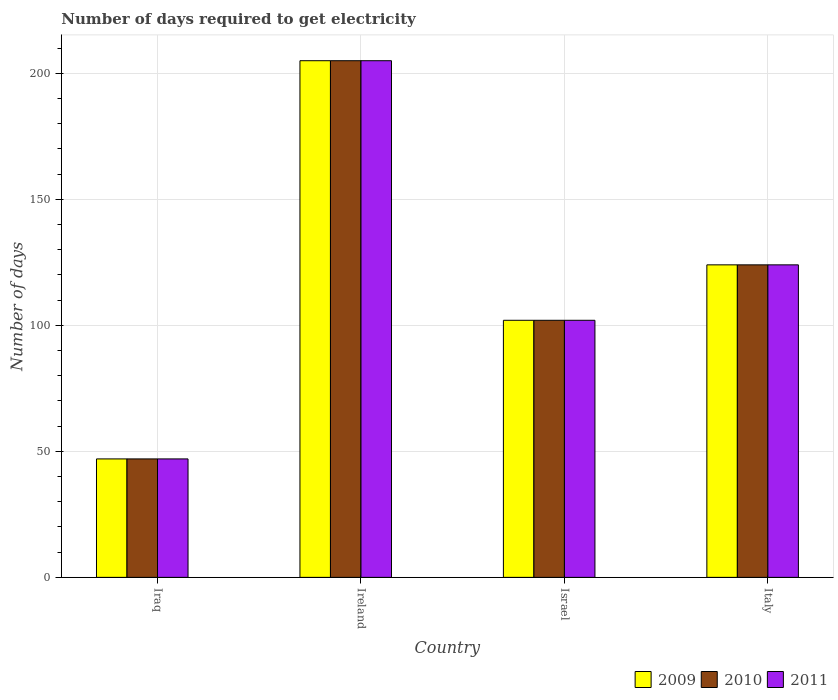How many different coloured bars are there?
Ensure brevity in your answer.  3. Are the number of bars per tick equal to the number of legend labels?
Offer a very short reply. Yes. What is the label of the 1st group of bars from the left?
Offer a very short reply. Iraq. What is the number of days required to get electricity in in 2011 in Israel?
Ensure brevity in your answer.  102. Across all countries, what is the maximum number of days required to get electricity in in 2011?
Your response must be concise. 205. In which country was the number of days required to get electricity in in 2009 maximum?
Provide a short and direct response. Ireland. In which country was the number of days required to get electricity in in 2011 minimum?
Your answer should be very brief. Iraq. What is the total number of days required to get electricity in in 2010 in the graph?
Your answer should be compact. 478. What is the difference between the number of days required to get electricity in in 2011 in Ireland and that in Italy?
Ensure brevity in your answer.  81. What is the difference between the number of days required to get electricity in in 2010 in Italy and the number of days required to get electricity in in 2009 in Iraq?
Your answer should be compact. 77. What is the average number of days required to get electricity in in 2010 per country?
Give a very brief answer. 119.5. In how many countries, is the number of days required to get electricity in in 2011 greater than 20 days?
Your response must be concise. 4. What is the ratio of the number of days required to get electricity in in 2010 in Iraq to that in Ireland?
Offer a terse response. 0.23. Is the difference between the number of days required to get electricity in in 2009 in Iraq and Ireland greater than the difference between the number of days required to get electricity in in 2011 in Iraq and Ireland?
Offer a very short reply. No. What is the difference between the highest and the second highest number of days required to get electricity in in 2011?
Your answer should be very brief. -81. What is the difference between the highest and the lowest number of days required to get electricity in in 2009?
Your answer should be very brief. 158. What does the 2nd bar from the left in Ireland represents?
Your response must be concise. 2010. What does the 3rd bar from the right in Italy represents?
Your answer should be very brief. 2009. How many bars are there?
Offer a terse response. 12. Are all the bars in the graph horizontal?
Your answer should be very brief. No. How many countries are there in the graph?
Keep it short and to the point. 4. What is the difference between two consecutive major ticks on the Y-axis?
Offer a terse response. 50. Does the graph contain any zero values?
Make the answer very short. No. Does the graph contain grids?
Your response must be concise. Yes. How are the legend labels stacked?
Make the answer very short. Horizontal. What is the title of the graph?
Make the answer very short. Number of days required to get electricity. Does "1998" appear as one of the legend labels in the graph?
Keep it short and to the point. No. What is the label or title of the X-axis?
Make the answer very short. Country. What is the label or title of the Y-axis?
Ensure brevity in your answer.  Number of days. What is the Number of days of 2009 in Iraq?
Give a very brief answer. 47. What is the Number of days in 2011 in Iraq?
Your answer should be very brief. 47. What is the Number of days in 2009 in Ireland?
Ensure brevity in your answer.  205. What is the Number of days of 2010 in Ireland?
Give a very brief answer. 205. What is the Number of days in 2011 in Ireland?
Ensure brevity in your answer.  205. What is the Number of days of 2009 in Israel?
Your answer should be very brief. 102. What is the Number of days of 2010 in Israel?
Provide a short and direct response. 102. What is the Number of days in 2011 in Israel?
Your answer should be very brief. 102. What is the Number of days in 2009 in Italy?
Offer a terse response. 124. What is the Number of days in 2010 in Italy?
Provide a succinct answer. 124. What is the Number of days in 2011 in Italy?
Provide a short and direct response. 124. Across all countries, what is the maximum Number of days of 2009?
Ensure brevity in your answer.  205. Across all countries, what is the maximum Number of days in 2010?
Your answer should be compact. 205. Across all countries, what is the maximum Number of days in 2011?
Ensure brevity in your answer.  205. What is the total Number of days of 2009 in the graph?
Provide a short and direct response. 478. What is the total Number of days in 2010 in the graph?
Offer a very short reply. 478. What is the total Number of days in 2011 in the graph?
Keep it short and to the point. 478. What is the difference between the Number of days of 2009 in Iraq and that in Ireland?
Provide a short and direct response. -158. What is the difference between the Number of days of 2010 in Iraq and that in Ireland?
Provide a succinct answer. -158. What is the difference between the Number of days of 2011 in Iraq and that in Ireland?
Your answer should be very brief. -158. What is the difference between the Number of days in 2009 in Iraq and that in Israel?
Ensure brevity in your answer.  -55. What is the difference between the Number of days of 2010 in Iraq and that in Israel?
Ensure brevity in your answer.  -55. What is the difference between the Number of days of 2011 in Iraq and that in Israel?
Offer a terse response. -55. What is the difference between the Number of days of 2009 in Iraq and that in Italy?
Your response must be concise. -77. What is the difference between the Number of days in 2010 in Iraq and that in Italy?
Provide a succinct answer. -77. What is the difference between the Number of days in 2011 in Iraq and that in Italy?
Make the answer very short. -77. What is the difference between the Number of days of 2009 in Ireland and that in Israel?
Ensure brevity in your answer.  103. What is the difference between the Number of days in 2010 in Ireland and that in Israel?
Provide a short and direct response. 103. What is the difference between the Number of days in 2011 in Ireland and that in Israel?
Offer a terse response. 103. What is the difference between the Number of days of 2009 in Ireland and that in Italy?
Provide a short and direct response. 81. What is the difference between the Number of days of 2011 in Ireland and that in Italy?
Offer a terse response. 81. What is the difference between the Number of days in 2009 in Israel and that in Italy?
Give a very brief answer. -22. What is the difference between the Number of days of 2010 in Israel and that in Italy?
Offer a terse response. -22. What is the difference between the Number of days of 2011 in Israel and that in Italy?
Offer a very short reply. -22. What is the difference between the Number of days in 2009 in Iraq and the Number of days in 2010 in Ireland?
Provide a short and direct response. -158. What is the difference between the Number of days in 2009 in Iraq and the Number of days in 2011 in Ireland?
Ensure brevity in your answer.  -158. What is the difference between the Number of days of 2010 in Iraq and the Number of days of 2011 in Ireland?
Offer a terse response. -158. What is the difference between the Number of days in 2009 in Iraq and the Number of days in 2010 in Israel?
Your answer should be compact. -55. What is the difference between the Number of days in 2009 in Iraq and the Number of days in 2011 in Israel?
Offer a terse response. -55. What is the difference between the Number of days of 2010 in Iraq and the Number of days of 2011 in Israel?
Provide a succinct answer. -55. What is the difference between the Number of days of 2009 in Iraq and the Number of days of 2010 in Italy?
Ensure brevity in your answer.  -77. What is the difference between the Number of days in 2009 in Iraq and the Number of days in 2011 in Italy?
Offer a very short reply. -77. What is the difference between the Number of days of 2010 in Iraq and the Number of days of 2011 in Italy?
Provide a short and direct response. -77. What is the difference between the Number of days of 2009 in Ireland and the Number of days of 2010 in Israel?
Offer a terse response. 103. What is the difference between the Number of days of 2009 in Ireland and the Number of days of 2011 in Israel?
Make the answer very short. 103. What is the difference between the Number of days in 2010 in Ireland and the Number of days in 2011 in Israel?
Offer a very short reply. 103. What is the difference between the Number of days in 2009 in Ireland and the Number of days in 2010 in Italy?
Ensure brevity in your answer.  81. What is the average Number of days of 2009 per country?
Your response must be concise. 119.5. What is the average Number of days of 2010 per country?
Ensure brevity in your answer.  119.5. What is the average Number of days in 2011 per country?
Your answer should be compact. 119.5. What is the difference between the Number of days of 2009 and Number of days of 2010 in Iraq?
Your answer should be compact. 0. What is the difference between the Number of days of 2009 and Number of days of 2011 in Iraq?
Provide a short and direct response. 0. What is the difference between the Number of days in 2010 and Number of days in 2011 in Iraq?
Ensure brevity in your answer.  0. What is the difference between the Number of days of 2009 and Number of days of 2010 in Ireland?
Offer a very short reply. 0. What is the difference between the Number of days of 2009 and Number of days of 2011 in Israel?
Offer a very short reply. 0. What is the difference between the Number of days of 2010 and Number of days of 2011 in Israel?
Give a very brief answer. 0. What is the ratio of the Number of days in 2009 in Iraq to that in Ireland?
Keep it short and to the point. 0.23. What is the ratio of the Number of days in 2010 in Iraq to that in Ireland?
Make the answer very short. 0.23. What is the ratio of the Number of days of 2011 in Iraq to that in Ireland?
Your response must be concise. 0.23. What is the ratio of the Number of days in 2009 in Iraq to that in Israel?
Keep it short and to the point. 0.46. What is the ratio of the Number of days in 2010 in Iraq to that in Israel?
Ensure brevity in your answer.  0.46. What is the ratio of the Number of days in 2011 in Iraq to that in Israel?
Your answer should be compact. 0.46. What is the ratio of the Number of days in 2009 in Iraq to that in Italy?
Keep it short and to the point. 0.38. What is the ratio of the Number of days in 2010 in Iraq to that in Italy?
Offer a very short reply. 0.38. What is the ratio of the Number of days of 2011 in Iraq to that in Italy?
Your response must be concise. 0.38. What is the ratio of the Number of days of 2009 in Ireland to that in Israel?
Ensure brevity in your answer.  2.01. What is the ratio of the Number of days of 2010 in Ireland to that in Israel?
Your answer should be very brief. 2.01. What is the ratio of the Number of days of 2011 in Ireland to that in Israel?
Ensure brevity in your answer.  2.01. What is the ratio of the Number of days of 2009 in Ireland to that in Italy?
Your answer should be very brief. 1.65. What is the ratio of the Number of days of 2010 in Ireland to that in Italy?
Provide a succinct answer. 1.65. What is the ratio of the Number of days of 2011 in Ireland to that in Italy?
Ensure brevity in your answer.  1.65. What is the ratio of the Number of days of 2009 in Israel to that in Italy?
Make the answer very short. 0.82. What is the ratio of the Number of days of 2010 in Israel to that in Italy?
Your response must be concise. 0.82. What is the ratio of the Number of days of 2011 in Israel to that in Italy?
Provide a succinct answer. 0.82. What is the difference between the highest and the second highest Number of days in 2010?
Provide a succinct answer. 81. What is the difference between the highest and the second highest Number of days in 2011?
Make the answer very short. 81. What is the difference between the highest and the lowest Number of days in 2009?
Provide a short and direct response. 158. What is the difference between the highest and the lowest Number of days of 2010?
Give a very brief answer. 158. What is the difference between the highest and the lowest Number of days of 2011?
Your answer should be compact. 158. 